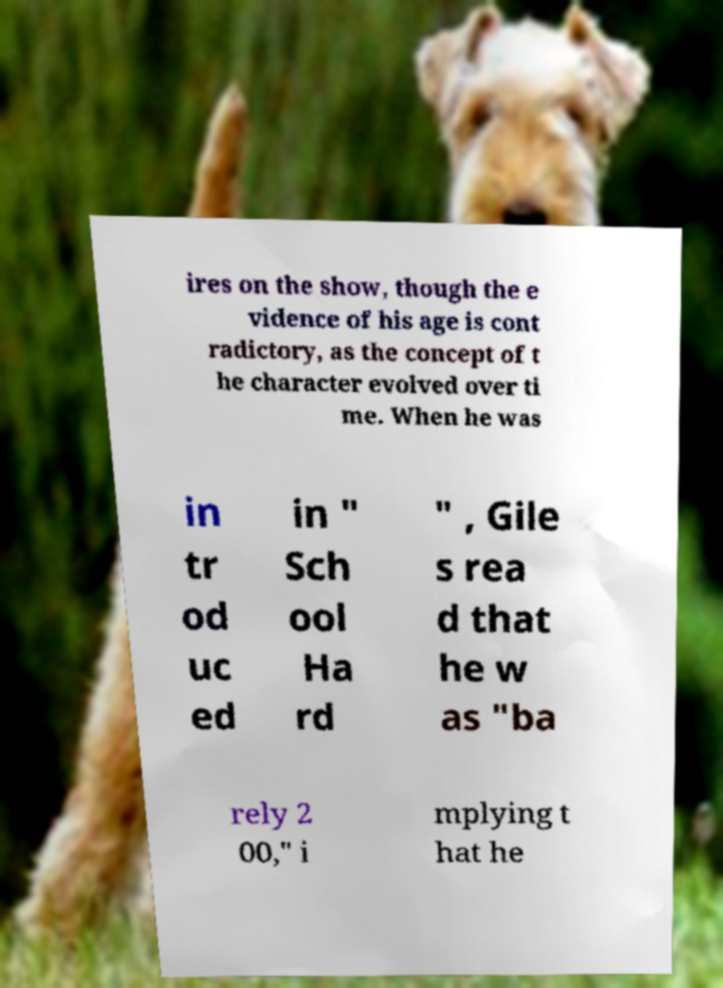Please read and relay the text visible in this image. What does it say? ires on the show, though the e vidence of his age is cont radictory, as the concept of t he character evolved over ti me. When he was in tr od uc ed in " Sch ool Ha rd " , Gile s rea d that he w as "ba rely 2 00," i mplying t hat he 